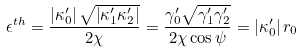<formula> <loc_0><loc_0><loc_500><loc_500>\epsilon ^ { t h } = \frac { \left | \kappa _ { 0 } ^ { \prime } \right | \sqrt { \left | \kappa _ { 1 } ^ { \prime } \kappa _ { 2 } ^ { \prime } \right | } } { 2 \chi } = \frac { \gamma _ { 0 } ^ { \prime } \sqrt { \gamma _ { 1 } ^ { \prime } \gamma _ { 2 } ^ { \prime } } } { 2 \chi \cos \psi } = \left | \kappa _ { 0 } ^ { \prime } \right | r _ { 0 }</formula> 